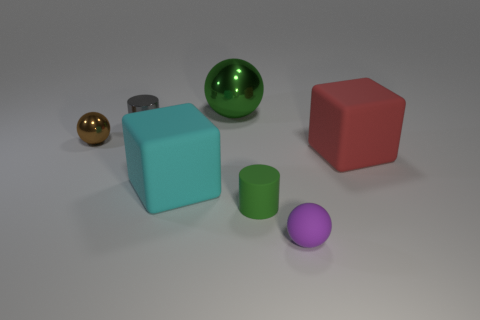How many small objects are in front of the red matte object and behind the rubber ball?
Your response must be concise. 1. There is a green object behind the small brown shiny thing; what material is it?
Give a very brief answer. Metal. There is a red block that is the same material as the small green cylinder; what size is it?
Your response must be concise. Large. There is a metal ball that is in front of the large green object; does it have the same size as the rubber cube that is to the left of the red matte thing?
Give a very brief answer. No. There is a purple thing that is the same size as the green rubber object; what is its material?
Your answer should be very brief. Rubber. What material is the tiny thing that is to the left of the big metallic ball and on the right side of the brown object?
Your answer should be compact. Metal. Is there a green cylinder?
Your answer should be very brief. Yes. Do the large shiny thing and the cylinder that is in front of the tiny brown sphere have the same color?
Make the answer very short. Yes. There is a ball that is the same color as the tiny rubber cylinder; what material is it?
Ensure brevity in your answer.  Metal. What is the shape of the rubber thing to the right of the ball in front of the matte object that is to the right of the purple matte thing?
Provide a succinct answer. Cube. 